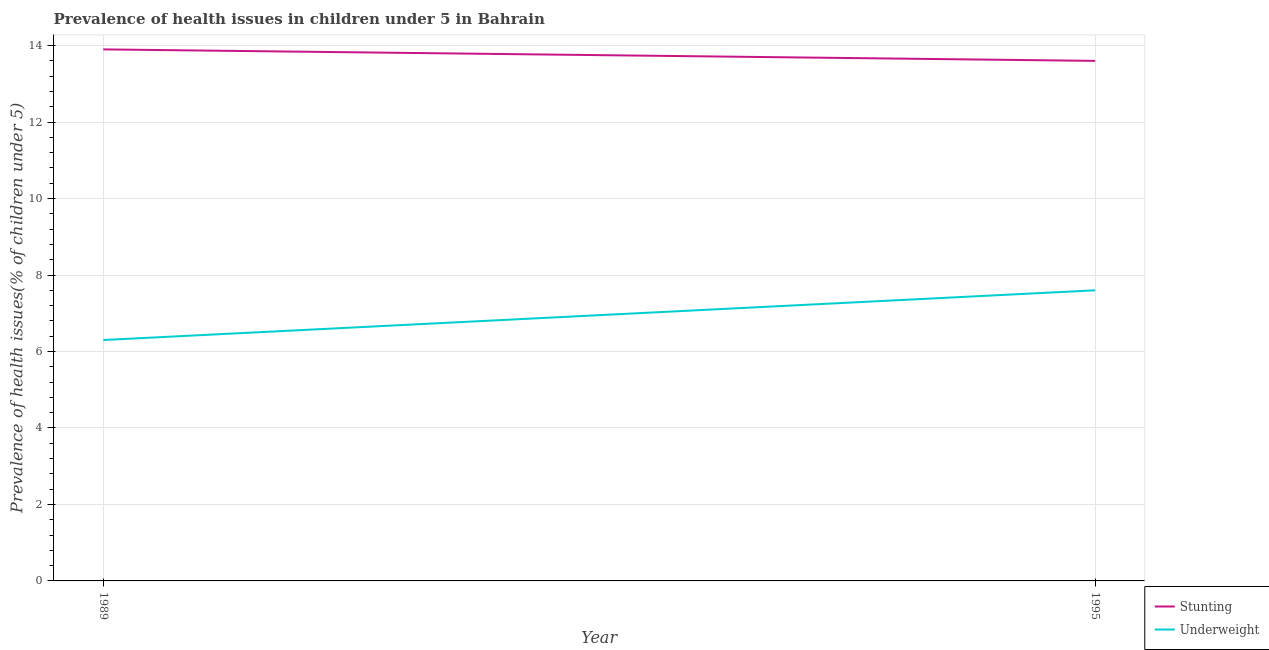How many different coloured lines are there?
Keep it short and to the point. 2. Is the number of lines equal to the number of legend labels?
Provide a short and direct response. Yes. What is the percentage of stunted children in 1995?
Offer a terse response. 13.6. Across all years, what is the maximum percentage of underweight children?
Provide a short and direct response. 7.6. Across all years, what is the minimum percentage of stunted children?
Make the answer very short. 13.6. What is the total percentage of stunted children in the graph?
Offer a terse response. 27.5. What is the difference between the percentage of underweight children in 1989 and that in 1995?
Your response must be concise. -1.3. What is the difference between the percentage of underweight children in 1989 and the percentage of stunted children in 1995?
Offer a terse response. -7.3. What is the average percentage of underweight children per year?
Make the answer very short. 6.95. In the year 1989, what is the difference between the percentage of underweight children and percentage of stunted children?
Your response must be concise. -7.6. In how many years, is the percentage of stunted children greater than 1.6 %?
Make the answer very short. 2. What is the ratio of the percentage of underweight children in 1989 to that in 1995?
Offer a terse response. 0.83. Is the percentage of stunted children in 1989 less than that in 1995?
Ensure brevity in your answer.  No. Is the percentage of underweight children strictly less than the percentage of stunted children over the years?
Give a very brief answer. Yes. How many lines are there?
Provide a succinct answer. 2. Does the graph contain any zero values?
Make the answer very short. No. How are the legend labels stacked?
Give a very brief answer. Vertical. What is the title of the graph?
Provide a succinct answer. Prevalence of health issues in children under 5 in Bahrain. What is the label or title of the Y-axis?
Make the answer very short. Prevalence of health issues(% of children under 5). What is the Prevalence of health issues(% of children under 5) of Stunting in 1989?
Ensure brevity in your answer.  13.9. What is the Prevalence of health issues(% of children under 5) of Underweight in 1989?
Keep it short and to the point. 6.3. What is the Prevalence of health issues(% of children under 5) in Stunting in 1995?
Provide a short and direct response. 13.6. What is the Prevalence of health issues(% of children under 5) of Underweight in 1995?
Your answer should be compact. 7.6. Across all years, what is the maximum Prevalence of health issues(% of children under 5) of Stunting?
Ensure brevity in your answer.  13.9. Across all years, what is the maximum Prevalence of health issues(% of children under 5) of Underweight?
Make the answer very short. 7.6. Across all years, what is the minimum Prevalence of health issues(% of children under 5) in Stunting?
Your answer should be compact. 13.6. Across all years, what is the minimum Prevalence of health issues(% of children under 5) of Underweight?
Your response must be concise. 6.3. What is the total Prevalence of health issues(% of children under 5) in Underweight in the graph?
Make the answer very short. 13.9. What is the difference between the Prevalence of health issues(% of children under 5) of Stunting in 1989 and that in 1995?
Provide a succinct answer. 0.3. What is the difference between the Prevalence of health issues(% of children under 5) of Underweight in 1989 and that in 1995?
Ensure brevity in your answer.  -1.3. What is the difference between the Prevalence of health issues(% of children under 5) of Stunting in 1989 and the Prevalence of health issues(% of children under 5) of Underweight in 1995?
Offer a very short reply. 6.3. What is the average Prevalence of health issues(% of children under 5) in Stunting per year?
Your answer should be compact. 13.75. What is the average Prevalence of health issues(% of children under 5) in Underweight per year?
Give a very brief answer. 6.95. In the year 1995, what is the difference between the Prevalence of health issues(% of children under 5) of Stunting and Prevalence of health issues(% of children under 5) of Underweight?
Your answer should be compact. 6. What is the ratio of the Prevalence of health issues(% of children under 5) of Stunting in 1989 to that in 1995?
Give a very brief answer. 1.02. What is the ratio of the Prevalence of health issues(% of children under 5) in Underweight in 1989 to that in 1995?
Give a very brief answer. 0.83. 